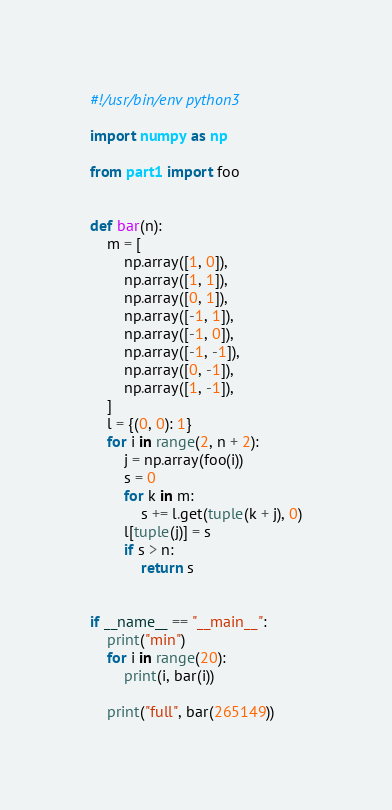<code> <loc_0><loc_0><loc_500><loc_500><_Python_>#!/usr/bin/env python3

import numpy as np

from part1 import foo


def bar(n):
    m = [
        np.array([1, 0]),
        np.array([1, 1]),
        np.array([0, 1]),
        np.array([-1, 1]),
        np.array([-1, 0]),
        np.array([-1, -1]),
        np.array([0, -1]),
        np.array([1, -1]),
    ]
    l = {(0, 0): 1}
    for i in range(2, n + 2):
        j = np.array(foo(i))
        s = 0
        for k in m:
            s += l.get(tuple(k + j), 0)
        l[tuple(j)] = s
        if s > n:
            return s


if __name__ == "__main__":
    print("min")
    for i in range(20):
        print(i, bar(i))

    print("full", bar(265149))
</code> 